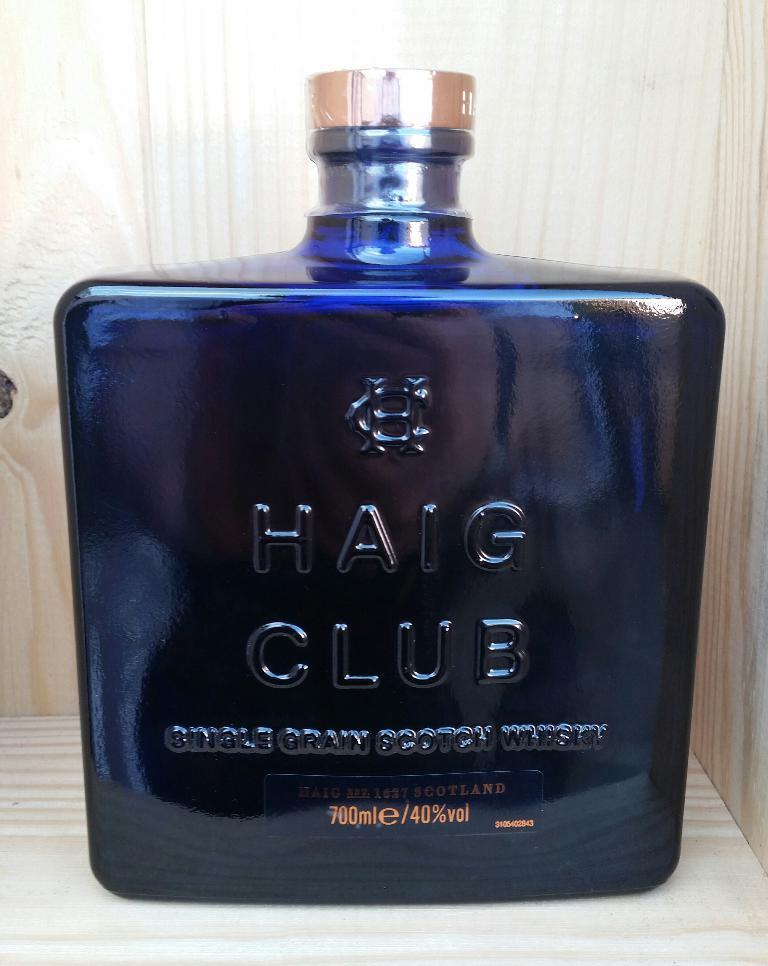<image>
Provide a brief description of the given image. a bottle of haig club 700ml cologne in a tinted blue bottle 